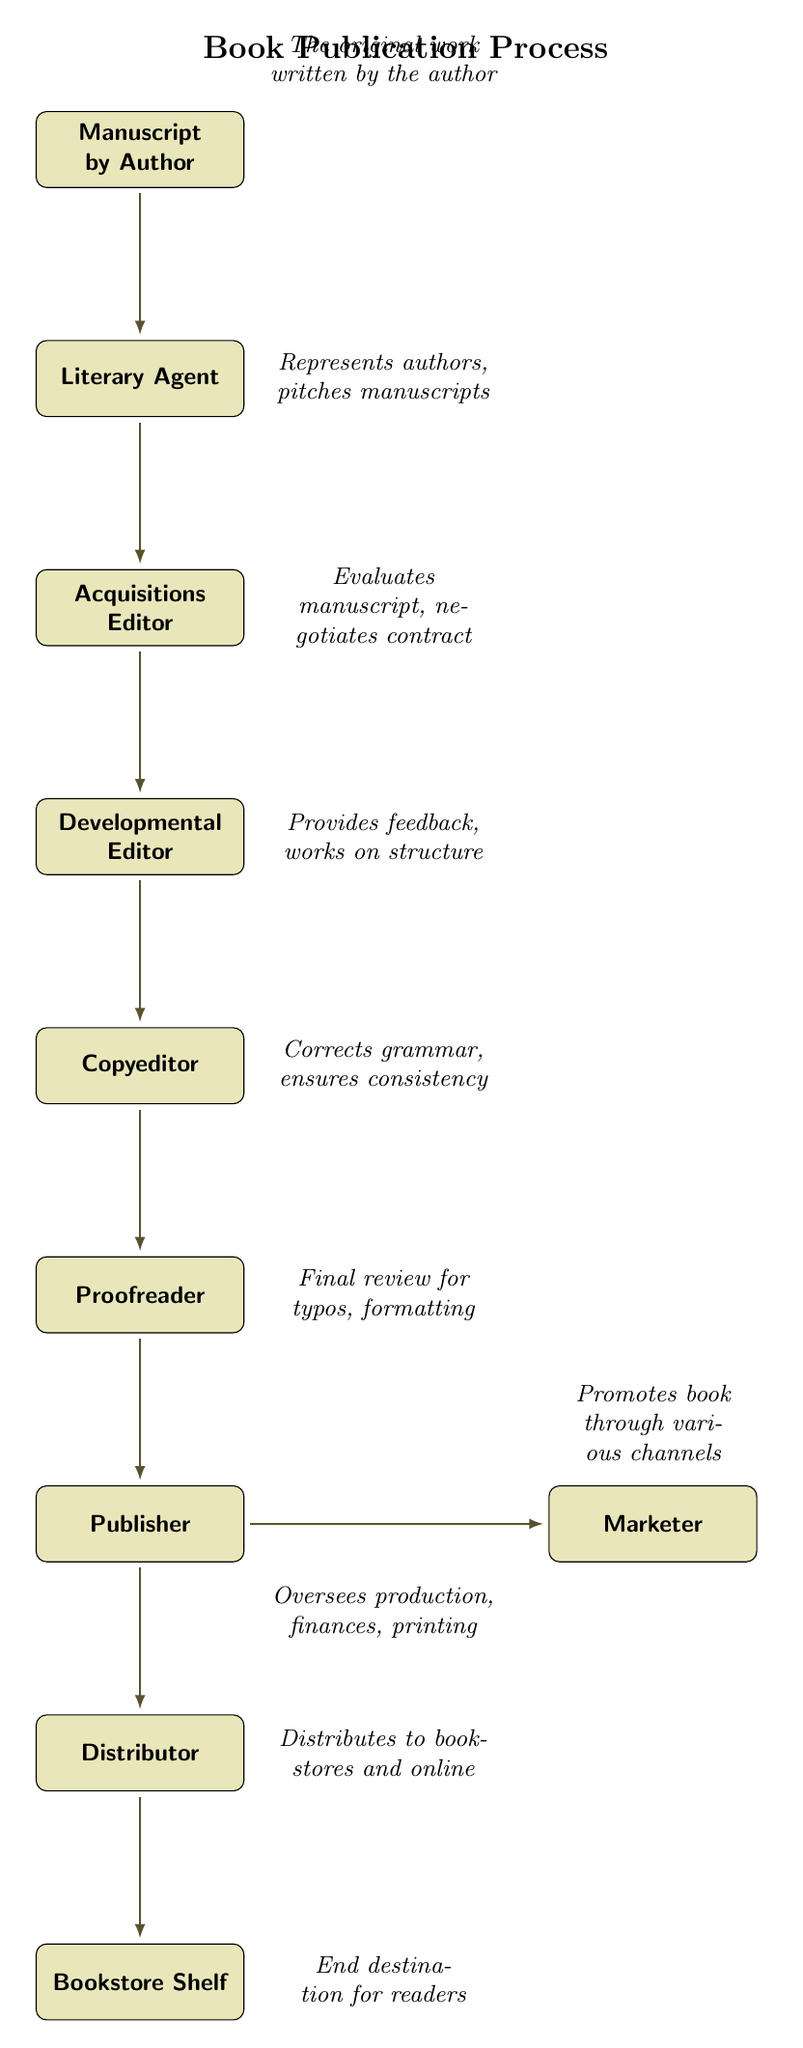What is the first step in the book publication process? The diagram begins with the "Manuscript by Author" node, indicating that it is the initial step in the process.
Answer: Manuscript by Author Who reviews the manuscript after the Acquisitions Editor? The "Developmental Editor" follows the Acquisitions Editor in the flow, indicating they are responsible for providing feedback on the manuscript.
Answer: Developmental Editor How many roles are involved from the author to the bookstore shelf? Counting the nodes from "Manuscript by Author" to "Bookstore Shelf", there are a total of 9 roles or steps involved.
Answer: 9 What action does the Marketer perform? According to the diagram, the Marketer "Promotes book through various channels," indicating their role in marketing the book.
Answer: Promotes book through various channels What comes after the Proofreader in the publication flow? The arrow from the Proofreader leads directly to the Publisher, showing that the Proofreader’s role precedes that of the Publisher.
Answer: Publisher Which role represents authors and pitches manuscripts? The "Literary Agent" node clearly indicates that this role is focused on representing authors and pitching their works.
Answer: Literary Agent What is the final destination of the book after the Distributor? The flow leads from the Distributor to the "Bookstore Shelf", clearly indicating where the book ends up.
Answer: Bookstore Shelf What type of editor provides feedback on the manuscript's structure? The "Developmental Editor" is responsible for providing feedback and working on the manuscript's structure as noted in the diagram.
Answer: Developmental Editor Which node has two arrows emerging from it? The "Publisher" node has two arrows leading to both the Marketer and the Distributor, indicating it plays a central role in the process.
Answer: Publisher 